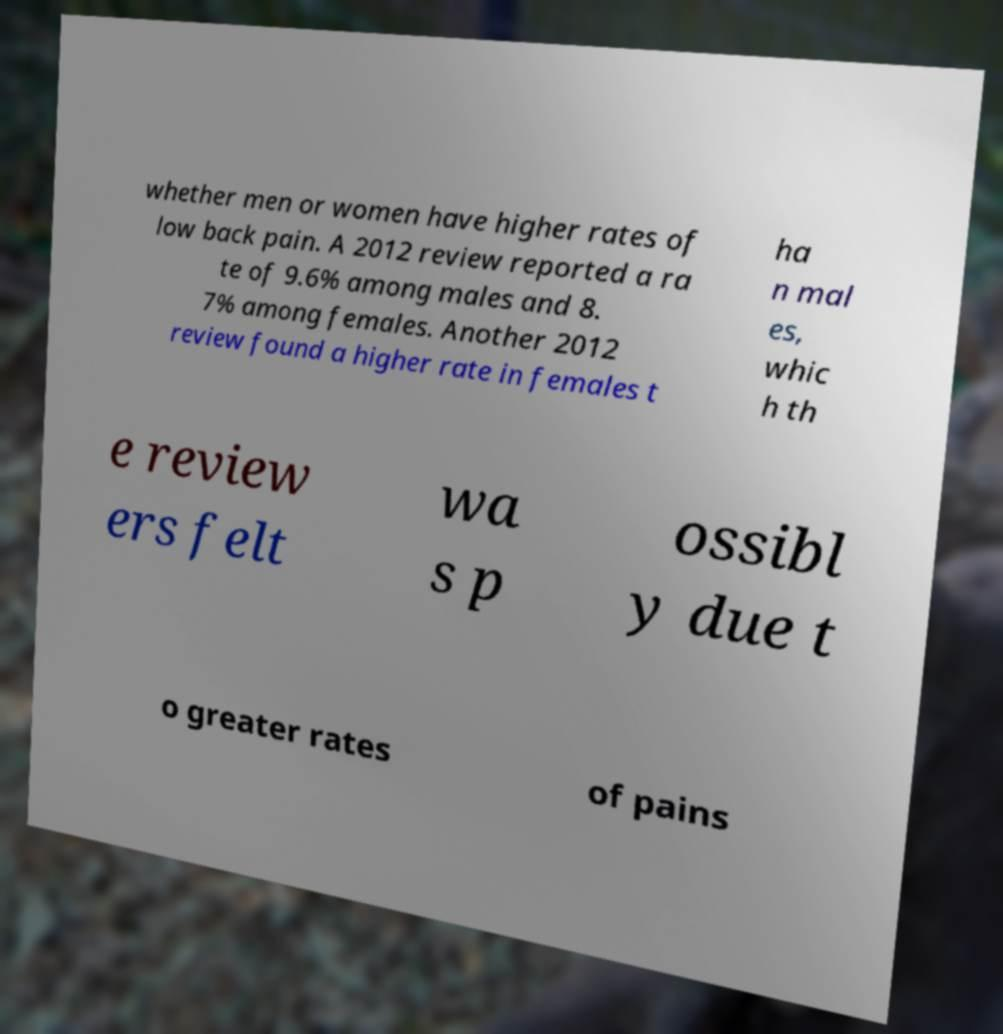Can you accurately transcribe the text from the provided image for me? whether men or women have higher rates of low back pain. A 2012 review reported a ra te of 9.6% among males and 8. 7% among females. Another 2012 review found a higher rate in females t ha n mal es, whic h th e review ers felt wa s p ossibl y due t o greater rates of pains 